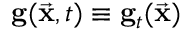<formula> <loc_0><loc_0><loc_500><loc_500>{ g } ( \vec { x } , t ) \equiv g _ { t } ( \vec { x } )</formula> 